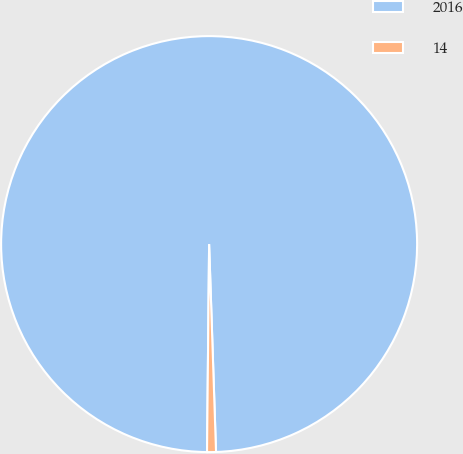Convert chart to OTSL. <chart><loc_0><loc_0><loc_500><loc_500><pie_chart><fcel>2016<fcel>14<nl><fcel>99.31%<fcel>0.69%<nl></chart> 